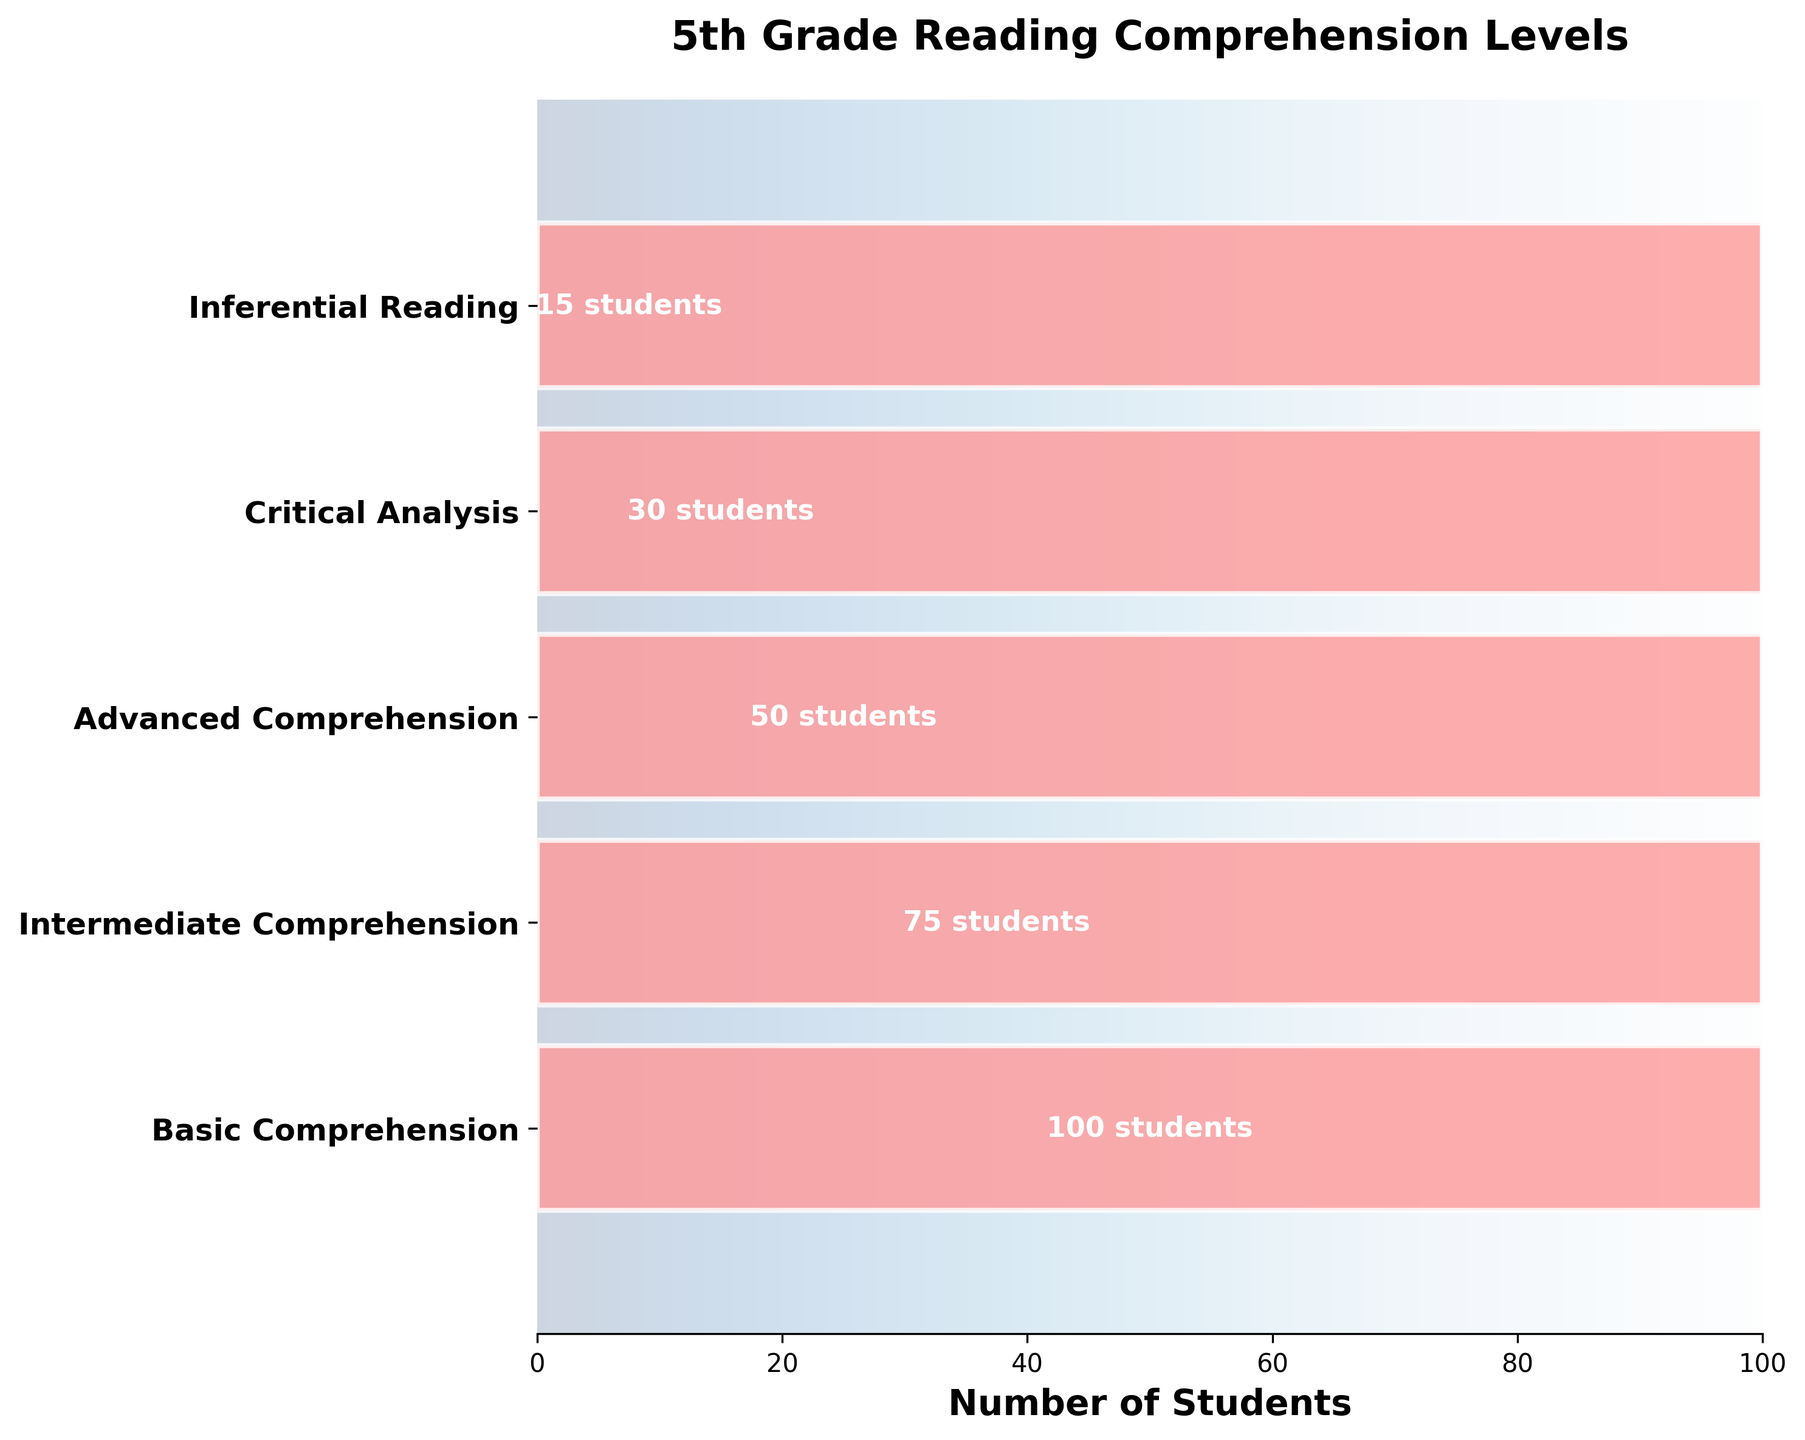What's the title of the chart? The title is located at the top center of the chart and it says: '5th Grade Reading Comprehension Levels'.
Answer: 5th Grade Reading Comprehension Levels How many levels of reading comprehension are represented in the chart? The chart has bars labeled with different levels of reading comprehension. By counting the distinct labels, we see there are five levels.
Answer: Five Which level has the highest number of students? The bars in the chart are labeled with the number of students. The 'Basic Comprehension' bar has the largest extent, indicating the highest number of students.
Answer: Basic Comprehension How many students are at the 'Critical Analysis' level? The number of students is labeled inside each bar. For 'Critical Analysis', the label inside the bar indicates the number of students.
Answer: 30 How many more students are at the 'Basic Comprehension' level compared to the 'Intermediate Comprehension' level? The 'Basic Comprehension' level has 100 students while the 'Intermediate Comprehension' level has 75 students. The difference is calculated as 100 - 75.
Answer: 25 What is the least represented level in terms of student numbers? The shortest bar in the chart represents the least number of students. The 'Inferential Reading' level has the shortest bar with 15 students.
Answer: Inferential Reading How many students are in the 'Advanced Comprehension' group? Each bar representing a level has a student count label. The 'Advanced Comprehension' bar shows the number of students in that group.
Answer: 50 What is the total number of students represented in the chart? Summing up the students from all levels: 100 (Basic) + 75 (Intermediate) + 50 (Advanced) + 30 (Critical) + 15 (Inferential) gives us the total.
Answer: 270 Are there more students in the 'Advanced Comprehension' or 'Critical Analysis' level? By comparing the student counts from the labels, 50 students are in 'Advanced Comprehension' and 30 in 'Critical Analysis'.
Answer: Advanced Comprehension Which levels have fewer than 50 students? Identify the levels that have fewer than 50 students by checking the labels: 'Critical Analysis' has 30, and 'Inferential Reading' has 15.
Answer: Critical Analysis, Inferential Reading 